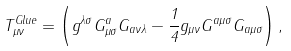Convert formula to latex. <formula><loc_0><loc_0><loc_500><loc_500>T ^ { G l u e } _ { \mu \nu } = \left ( g ^ { \lambda \sigma } G ^ { a } _ { \mu \sigma } G _ { a \nu \lambda } - \frac { 1 } { 4 } g _ { \mu \nu } G ^ { a \mu \sigma } G _ { a \mu \sigma } \right ) ,</formula> 